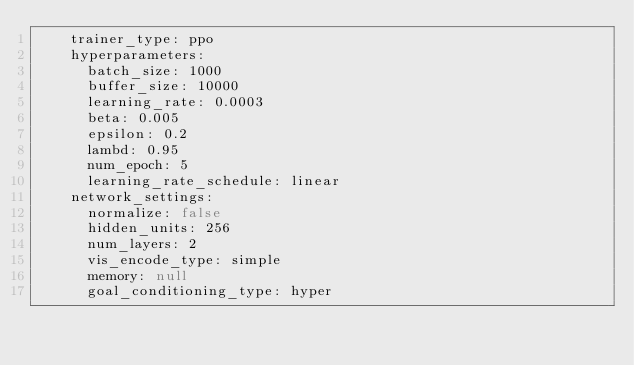<code> <loc_0><loc_0><loc_500><loc_500><_YAML_>    trainer_type: ppo
    hyperparameters:
      batch_size: 1000
      buffer_size: 10000
      learning_rate: 0.0003
      beta: 0.005
      epsilon: 0.2
      lambd: 0.95
      num_epoch: 5
      learning_rate_schedule: linear
    network_settings:
      normalize: false
      hidden_units: 256
      num_layers: 2
      vis_encode_type: simple
      memory: null
      goal_conditioning_type: hyper</code> 